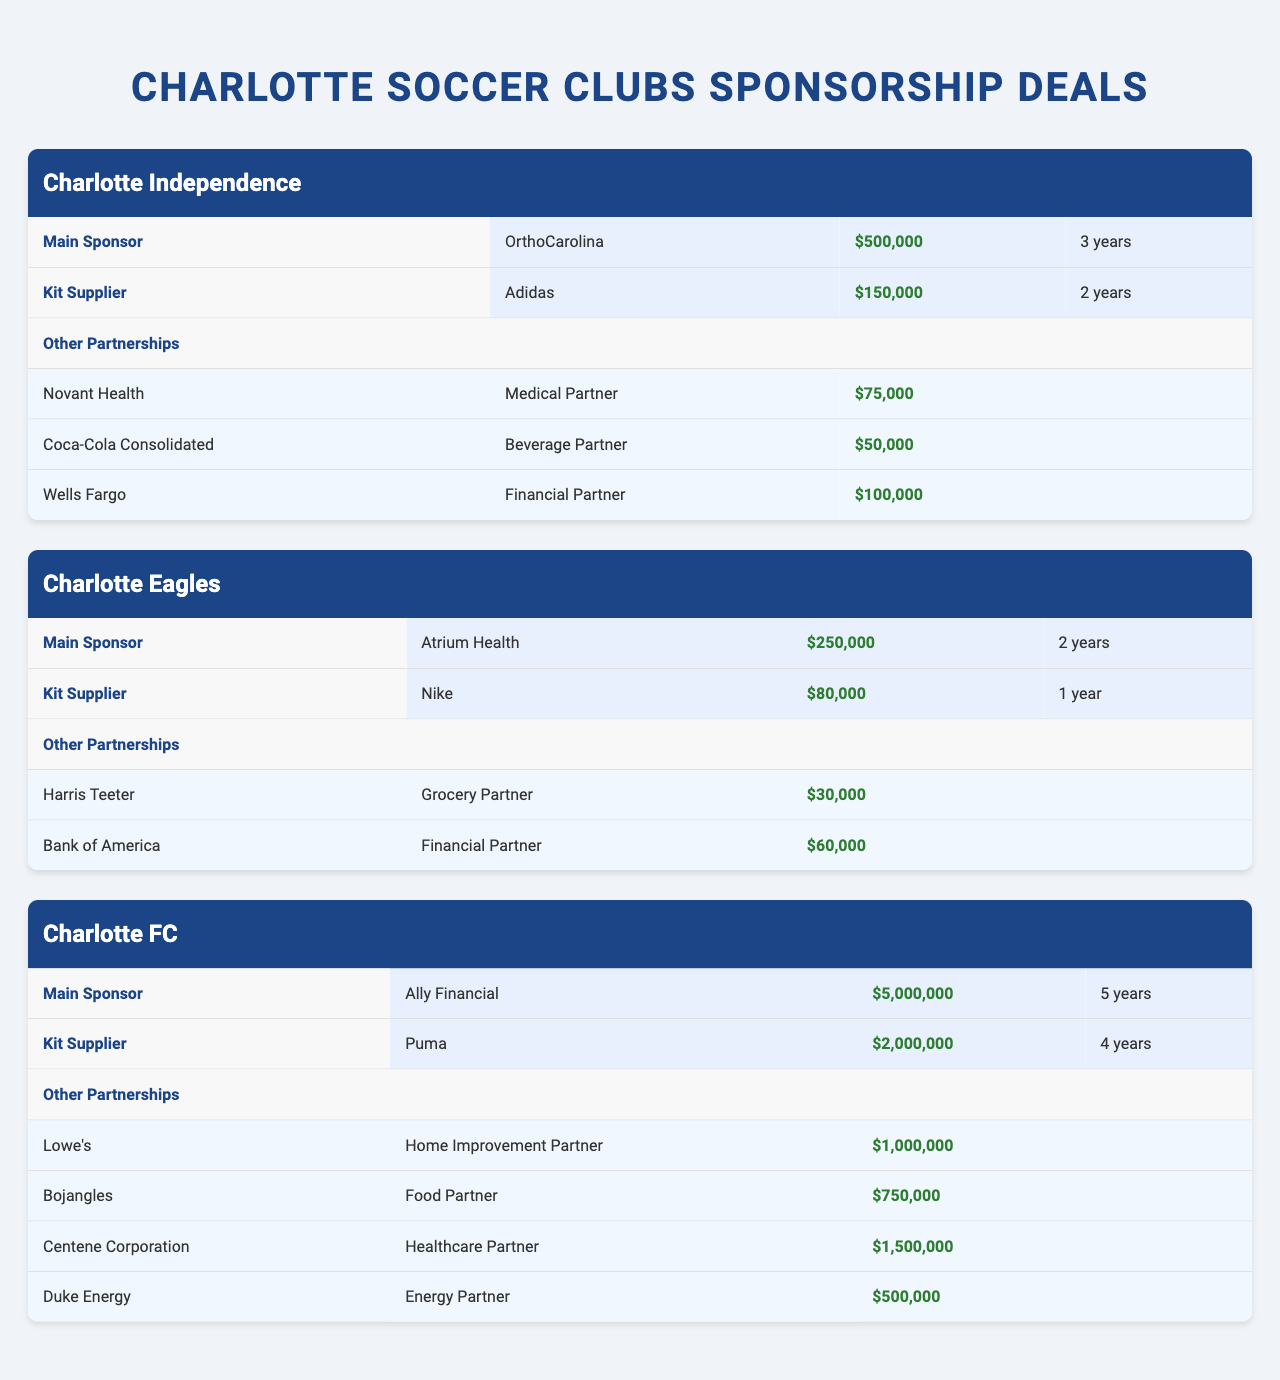What is the main sponsor for Charlotte Independence? The main sponsor for Charlotte Independence is listed in the table under the "Main Sponsor" section, which shows the name as "OrthoCarolina."
Answer: OrthoCarolina How long is the kit supplier deal for Charlotte FC? The duration of the kit supplier deal for Charlotte FC is mentioned in the "Kit Supplier" section, and it states "4 years."
Answer: 4 years Which club has the highest deal value for its main sponsorship? To find this, we compare the deal values of the main sponsors across clubs: Charlotte Independence has $500,000, Charlotte Eagles has $250,000, and Charlotte FC has $5,000,000. The highest is $5,000,000 for Charlotte FC.
Answer: Charlotte FC What is the total deal value of all partnerships for Charlotte Independence? The total deal value for Charlotte Independence can be calculated by summing the values of the main sponsor, kit supplier, and other partnerships. Main sponsorship ($500,000) + kit supplier ($150,000) + other partnerships ($75,000 + $50,000 + $100,000) = $500,000 + $150,000 + $225,000 = $875,000.
Answer: $875,000 Is the kit supplier for Charlotte Eagles more valuable than its main sponsor? We check the deal values: the kit supplier (Nike) deal is worth $80,000, while the main sponsor (Atrium Health) deal is $250,000. Since $80,000 is not greater than $250,000, the statement is false.
Answer: No How much greater is the total deal value of Charlotte FC's partnerships compared to Charlotte Independence's? First, we need to find the total deal values: Charlotte FC's main sponsor ($5,000,000) + kit supplier ($2,000,000) + other partnerships ($1,000,000 + $750,000 + $1,500,000 + $500,000) = $5,000,000 + $2,000,000 + $3,750,000 = $10,750,000. Charlotte Independence's total is $875,000. Differences 10,750,000 - 875,000 = 9,875,000.
Answer: $9,875,000 What type of partner is Wells Fargo for Charlotte Independence? The type of partner for Wells Fargo is detailed in the "Other Partnerships" section of Charlotte Independence, where it states "Financial Partner."
Answer: Financial Partner Which club has multiple beverage partnerships? By reviewing the partnership information for each club, we see that only Charlotte Independence has a beverage partnership listed (Coca-Cola Consolidated). Neither of the other clubs lists any beverage partners.
Answer: Charlotte Independence What is the sum of deal values for all partnerships of Charlotte FC? The deal values of Charlotte FC's other partnerships are: Lowe's ($1,000,000) + Bojangles ($750,000) + Centene Corporation ($1,500,000) + Duke Energy ($500,000) = $1,000,000 + $750,000 + $1,500,000 + $500,000 = $3,750,000.
Answer: $3,750,000 Did Charlotte Eagles secure a deal with a medical partner? The table states the partnerships for Charlotte Eagles, and there is no mention of a medical partner. The partnerships listed include a grocery and a financial partner. Thus the answer is false.
Answer: No 